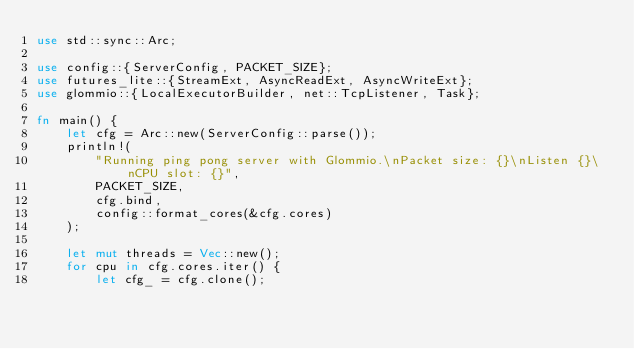<code> <loc_0><loc_0><loc_500><loc_500><_Rust_>use std::sync::Arc;

use config::{ServerConfig, PACKET_SIZE};
use futures_lite::{StreamExt, AsyncReadExt, AsyncWriteExt};
use glommio::{LocalExecutorBuilder, net::TcpListener, Task};

fn main() {
    let cfg = Arc::new(ServerConfig::parse());
    println!(
        "Running ping pong server with Glommio.\nPacket size: {}\nListen {}\nCPU slot: {}",
        PACKET_SIZE,
        cfg.bind,
        config::format_cores(&cfg.cores)
    );

    let mut threads = Vec::new();
    for cpu in cfg.cores.iter() {
        let cfg_ = cfg.clone();</code> 